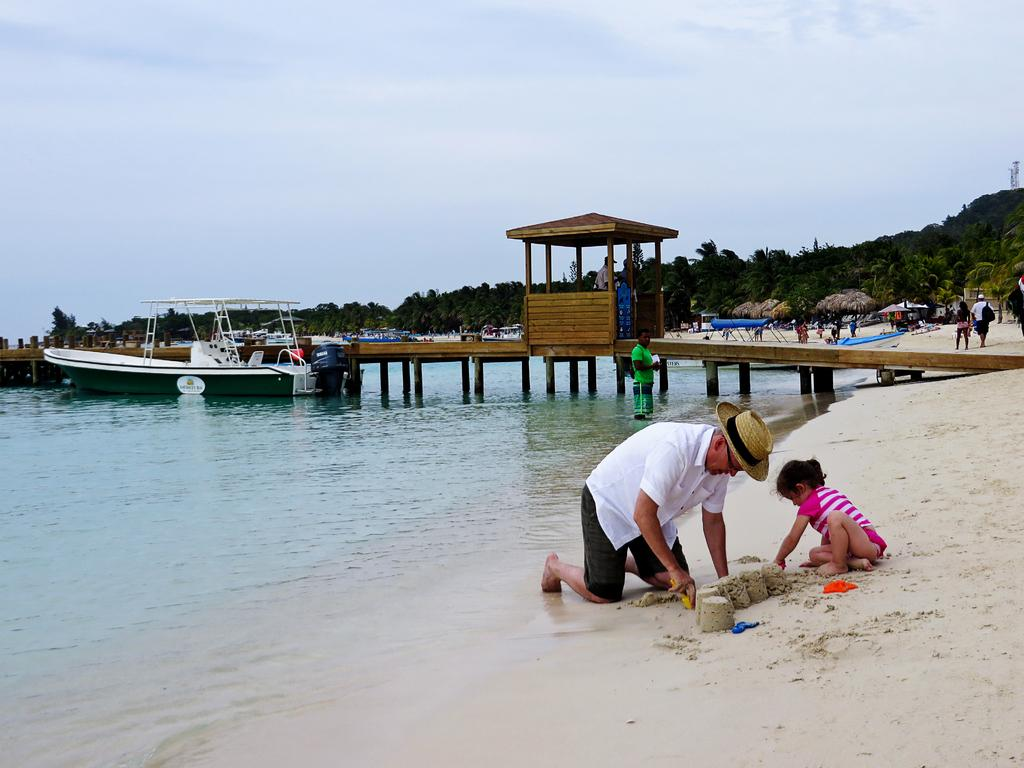What type of location is depicted in the image? There is a boat yard in the image. What type of vegetation can be seen in the image? There are trees in the image. What is on the ground in the image? There are objects on the ground in the image. Where is the boat located in the image? There is a boat on the water on the left side of the image. What is visible in the background of the image? The sky is visible in the background of the image. How many pairs of scissors are visible in the image? There are no scissors present in the image. What type of wood is used to build the boat in the image? There is no information about the type of wood used to build the boat in the image. 